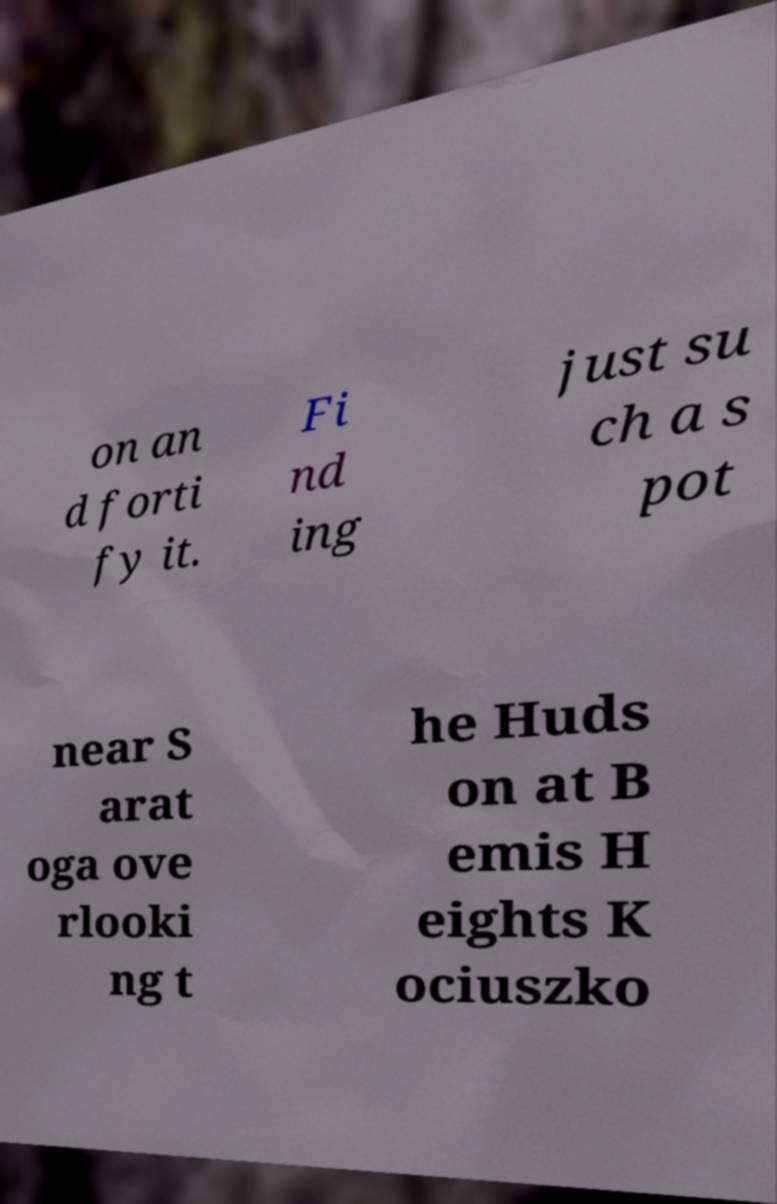Can you read and provide the text displayed in the image?This photo seems to have some interesting text. Can you extract and type it out for me? on an d forti fy it. Fi nd ing just su ch a s pot near S arat oga ove rlooki ng t he Huds on at B emis H eights K ociuszko 